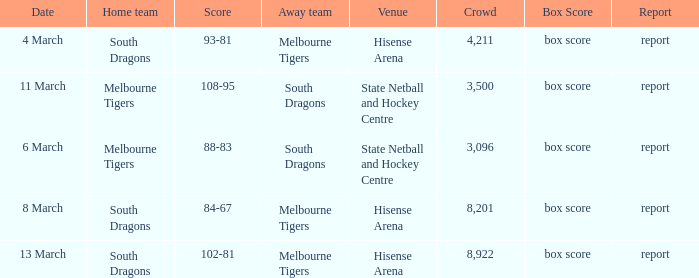Where was the venue with 3,096 in the crowd and against the Melbourne Tigers? Hisense Arena, Hisense Arena, Hisense Arena. 